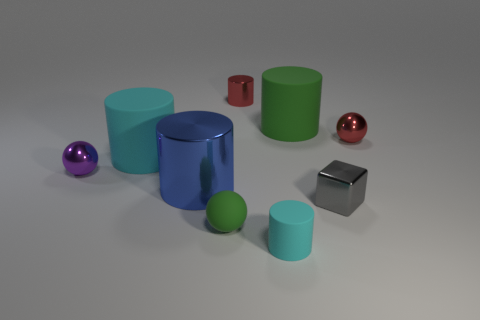What material is the small object that is the same color as the small metal cylinder?
Give a very brief answer. Metal. Is there anything else that is the same shape as the tiny gray metallic thing?
Give a very brief answer. No. Is the material of the cyan object that is behind the small block the same as the green thing that is behind the gray metallic object?
Your answer should be compact. Yes. What is the tiny green sphere made of?
Make the answer very short. Rubber. Are there more tiny green rubber spheres that are left of the small purple thing than large shiny cylinders?
Offer a terse response. No. What number of blue cylinders are behind the large rubber cylinder that is left of the cyan cylinder that is in front of the blue metal thing?
Your response must be concise. 0. There is a tiny thing that is in front of the purple thing and on the right side of the tiny cyan object; what material is it?
Provide a short and direct response. Metal. The shiny cube has what color?
Make the answer very short. Gray. Is the number of red metallic objects in front of the tiny purple metal ball greater than the number of large blue objects right of the large blue metal cylinder?
Make the answer very short. No. What is the color of the small metallic ball that is to the right of the tiny red metal cylinder?
Provide a succinct answer. Red. 